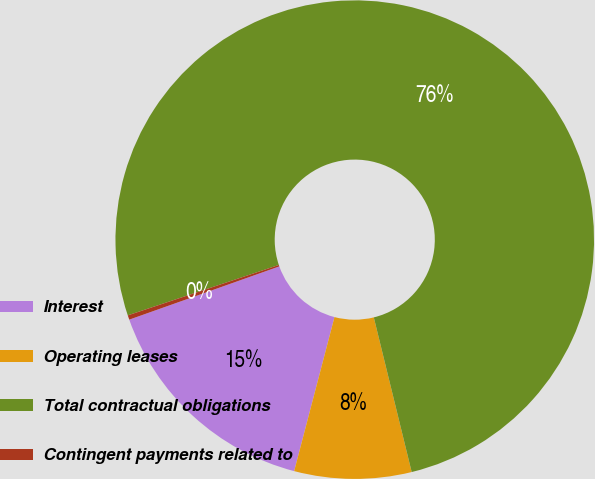Convert chart. <chart><loc_0><loc_0><loc_500><loc_500><pie_chart><fcel>Interest<fcel>Operating leases<fcel>Total contractual obligations<fcel>Contingent payments related to<nl><fcel>15.5%<fcel>7.9%<fcel>76.31%<fcel>0.3%<nl></chart> 